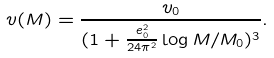<formula> <loc_0><loc_0><loc_500><loc_500>v ( M ) = \frac { v _ { 0 } } { ( 1 + \frac { e ^ { 2 } _ { 0 } } { 2 4 \pi ^ { 2 } } \log M / M _ { 0 } ) ^ { 3 } } .</formula> 